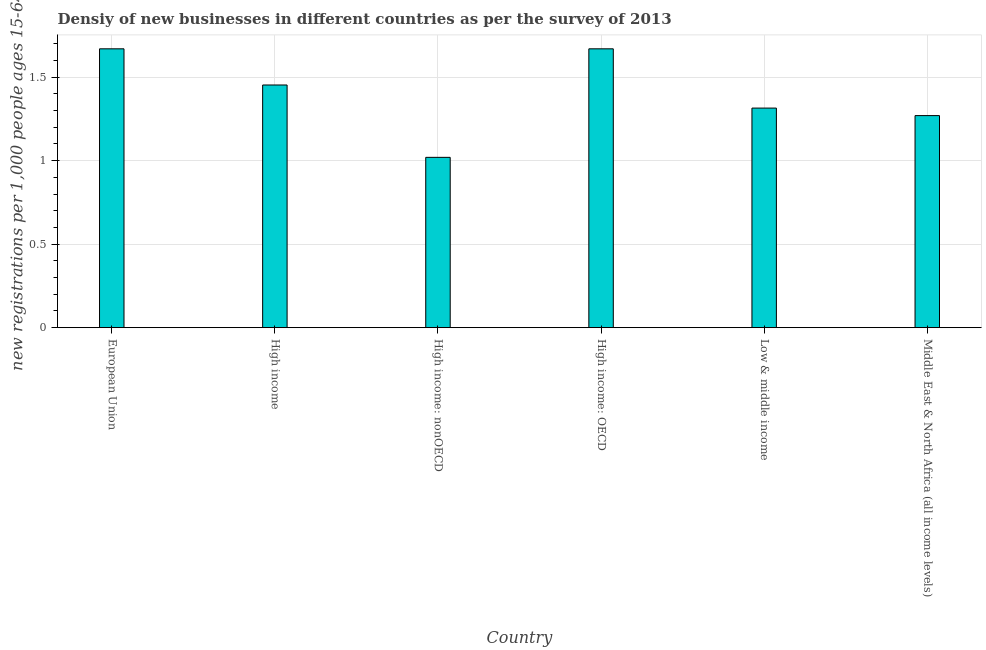Does the graph contain grids?
Your answer should be very brief. Yes. What is the title of the graph?
Provide a short and direct response. Densiy of new businesses in different countries as per the survey of 2013. What is the label or title of the Y-axis?
Provide a succinct answer. New registrations per 1,0 people ages 15-64. Across all countries, what is the maximum density of new business?
Provide a short and direct response. 1.67. Across all countries, what is the minimum density of new business?
Keep it short and to the point. 1.02. In which country was the density of new business maximum?
Make the answer very short. European Union. In which country was the density of new business minimum?
Your response must be concise. High income: nonOECD. What is the sum of the density of new business?
Make the answer very short. 8.4. What is the difference between the density of new business in High income: nonOECD and Low & middle income?
Give a very brief answer. -0.29. What is the average density of new business per country?
Your response must be concise. 1.4. What is the median density of new business?
Keep it short and to the point. 1.38. In how many countries, is the density of new business greater than 1.2 ?
Your answer should be very brief. 5. What is the ratio of the density of new business in European Union to that in Low & middle income?
Your answer should be compact. 1.27. Is the density of new business in High income less than that in Low & middle income?
Give a very brief answer. No. What is the difference between the highest and the second highest density of new business?
Your answer should be compact. 0. Is the sum of the density of new business in High income: OECD and Middle East & North Africa (all income levels) greater than the maximum density of new business across all countries?
Offer a very short reply. Yes. What is the difference between the highest and the lowest density of new business?
Keep it short and to the point. 0.65. Are all the bars in the graph horizontal?
Offer a very short reply. No. How many countries are there in the graph?
Your answer should be very brief. 6. Are the values on the major ticks of Y-axis written in scientific E-notation?
Offer a terse response. No. What is the new registrations per 1,000 people ages 15-64 in European Union?
Your answer should be very brief. 1.67. What is the new registrations per 1,000 people ages 15-64 in High income?
Provide a short and direct response. 1.45. What is the new registrations per 1,000 people ages 15-64 of High income: OECD?
Provide a short and direct response. 1.67. What is the new registrations per 1,000 people ages 15-64 in Low & middle income?
Offer a terse response. 1.31. What is the new registrations per 1,000 people ages 15-64 in Middle East & North Africa (all income levels)?
Your response must be concise. 1.27. What is the difference between the new registrations per 1,000 people ages 15-64 in European Union and High income?
Your answer should be compact. 0.22. What is the difference between the new registrations per 1,000 people ages 15-64 in European Union and High income: nonOECD?
Your response must be concise. 0.65. What is the difference between the new registrations per 1,000 people ages 15-64 in European Union and High income: OECD?
Ensure brevity in your answer.  0. What is the difference between the new registrations per 1,000 people ages 15-64 in European Union and Low & middle income?
Your answer should be compact. 0.35. What is the difference between the new registrations per 1,000 people ages 15-64 in European Union and Middle East & North Africa (all income levels)?
Provide a succinct answer. 0.4. What is the difference between the new registrations per 1,000 people ages 15-64 in High income and High income: nonOECD?
Provide a succinct answer. 0.43. What is the difference between the new registrations per 1,000 people ages 15-64 in High income and High income: OECD?
Your answer should be compact. -0.22. What is the difference between the new registrations per 1,000 people ages 15-64 in High income and Low & middle income?
Keep it short and to the point. 0.14. What is the difference between the new registrations per 1,000 people ages 15-64 in High income and Middle East & North Africa (all income levels)?
Provide a short and direct response. 0.18. What is the difference between the new registrations per 1,000 people ages 15-64 in High income: nonOECD and High income: OECD?
Offer a very short reply. -0.65. What is the difference between the new registrations per 1,000 people ages 15-64 in High income: nonOECD and Low & middle income?
Ensure brevity in your answer.  -0.29. What is the difference between the new registrations per 1,000 people ages 15-64 in High income: nonOECD and Middle East & North Africa (all income levels)?
Provide a succinct answer. -0.25. What is the difference between the new registrations per 1,000 people ages 15-64 in High income: OECD and Low & middle income?
Ensure brevity in your answer.  0.35. What is the difference between the new registrations per 1,000 people ages 15-64 in High income: OECD and Middle East & North Africa (all income levels)?
Keep it short and to the point. 0.4. What is the difference between the new registrations per 1,000 people ages 15-64 in Low & middle income and Middle East & North Africa (all income levels)?
Keep it short and to the point. 0.04. What is the ratio of the new registrations per 1,000 people ages 15-64 in European Union to that in High income?
Make the answer very short. 1.15. What is the ratio of the new registrations per 1,000 people ages 15-64 in European Union to that in High income: nonOECD?
Your response must be concise. 1.64. What is the ratio of the new registrations per 1,000 people ages 15-64 in European Union to that in High income: OECD?
Keep it short and to the point. 1. What is the ratio of the new registrations per 1,000 people ages 15-64 in European Union to that in Low & middle income?
Your answer should be compact. 1.27. What is the ratio of the new registrations per 1,000 people ages 15-64 in European Union to that in Middle East & North Africa (all income levels)?
Your answer should be very brief. 1.31. What is the ratio of the new registrations per 1,000 people ages 15-64 in High income to that in High income: nonOECD?
Keep it short and to the point. 1.43. What is the ratio of the new registrations per 1,000 people ages 15-64 in High income to that in High income: OECD?
Your answer should be compact. 0.87. What is the ratio of the new registrations per 1,000 people ages 15-64 in High income to that in Low & middle income?
Offer a very short reply. 1.1. What is the ratio of the new registrations per 1,000 people ages 15-64 in High income to that in Middle East & North Africa (all income levels)?
Your answer should be very brief. 1.14. What is the ratio of the new registrations per 1,000 people ages 15-64 in High income: nonOECD to that in High income: OECD?
Provide a short and direct response. 0.61. What is the ratio of the new registrations per 1,000 people ages 15-64 in High income: nonOECD to that in Low & middle income?
Your response must be concise. 0.78. What is the ratio of the new registrations per 1,000 people ages 15-64 in High income: nonOECD to that in Middle East & North Africa (all income levels)?
Your response must be concise. 0.8. What is the ratio of the new registrations per 1,000 people ages 15-64 in High income: OECD to that in Low & middle income?
Provide a succinct answer. 1.27. What is the ratio of the new registrations per 1,000 people ages 15-64 in High income: OECD to that in Middle East & North Africa (all income levels)?
Offer a terse response. 1.31. What is the ratio of the new registrations per 1,000 people ages 15-64 in Low & middle income to that in Middle East & North Africa (all income levels)?
Provide a succinct answer. 1.03. 